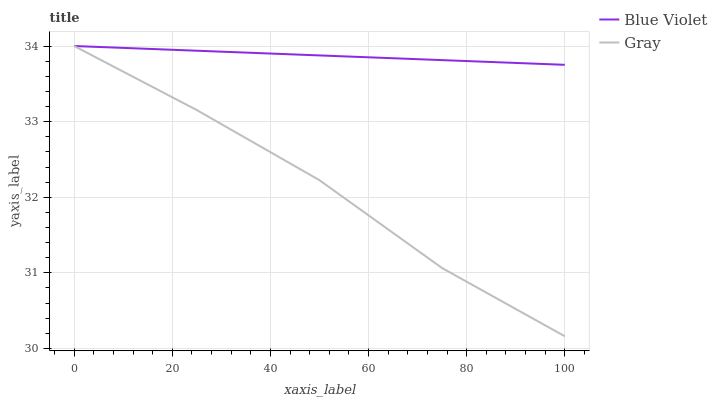Does Gray have the minimum area under the curve?
Answer yes or no. Yes. Does Blue Violet have the maximum area under the curve?
Answer yes or no. Yes. Does Blue Violet have the minimum area under the curve?
Answer yes or no. No. Is Blue Violet the smoothest?
Answer yes or no. Yes. Is Gray the roughest?
Answer yes or no. Yes. Is Blue Violet the roughest?
Answer yes or no. No. Does Blue Violet have the lowest value?
Answer yes or no. No. Does Blue Violet have the highest value?
Answer yes or no. Yes. 